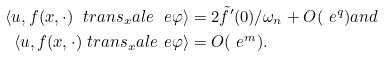Convert formula to latex. <formula><loc_0><loc_0><loc_500><loc_500>\langle u , f ( x , \cdot ) \ t r a n s _ { x } a l e _ { \ } e \varphi \rangle & = 2 \tilde { f } ^ { \prime } ( 0 ) / \omega _ { n } + O ( \ e ^ { q } ) a n d \\ \langle u , f ( x , \cdot ) \ t r a n s _ { x } a l e _ { \ } e \varphi \rangle & = O ( \ e ^ { m } ) .</formula> 